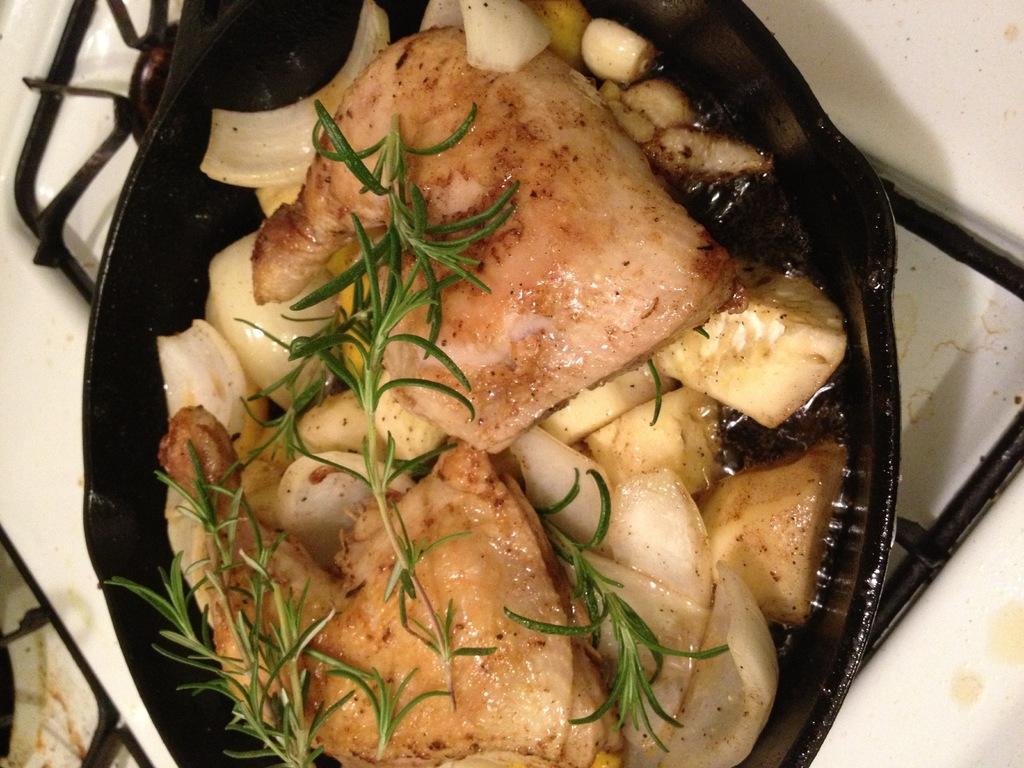Could you give a brief overview of what you see in this image? In this picture there is a food in the bowl. There is a bowl on the stove. 